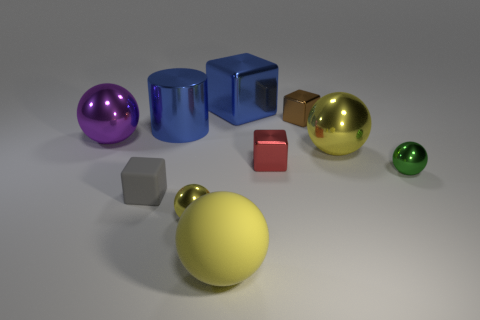There is a big thing that is the same color as the big metal cylinder; what is its shape?
Your response must be concise. Cube. Is the tiny object behind the large purple object made of the same material as the big sphere that is in front of the gray block?
Your answer should be compact. No. What shape is the blue shiny object to the left of the large yellow rubber object?
Provide a succinct answer. Cylinder. How many objects are green cylinders or objects to the left of the small red object?
Provide a succinct answer. 6. Do the big cube and the small red thing have the same material?
Provide a short and direct response. Yes. Are there the same number of small green shiny balls behind the small gray thing and yellow things that are to the left of the purple shiny object?
Your answer should be very brief. No. There is a large purple sphere; what number of cylinders are in front of it?
Your answer should be compact. 0. How many objects are either purple things or large yellow balls?
Your answer should be compact. 3. What number of brown shiny cylinders have the same size as the brown cube?
Offer a very short reply. 0. There is a small shiny object behind the yellow shiny ball that is on the right side of the large metal cube; what shape is it?
Make the answer very short. Cube. 